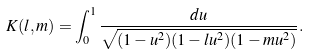Convert formula to latex. <formula><loc_0><loc_0><loc_500><loc_500>K ( l , m ) = \int _ { 0 } ^ { 1 } \frac { d u } { \sqrt { ( 1 - u ^ { 2 } ) ( 1 - l u ^ { 2 } ) ( 1 - m u ^ { 2 } ) } } .</formula> 